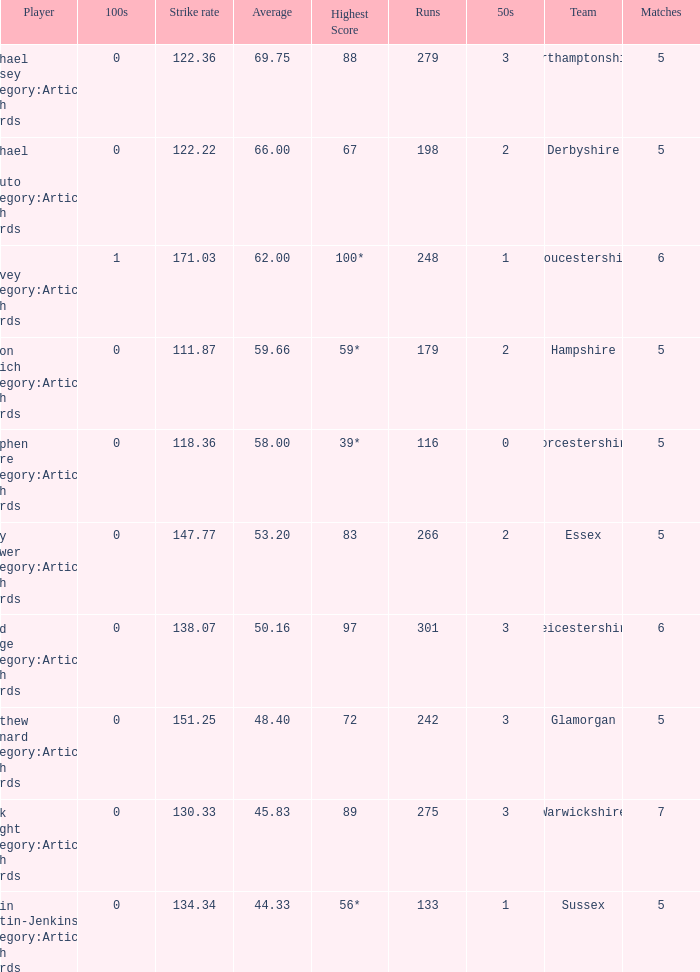What is the smallest amount of matches? 5.0. 